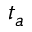Convert formula to latex. <formula><loc_0><loc_0><loc_500><loc_500>t _ { a }</formula> 